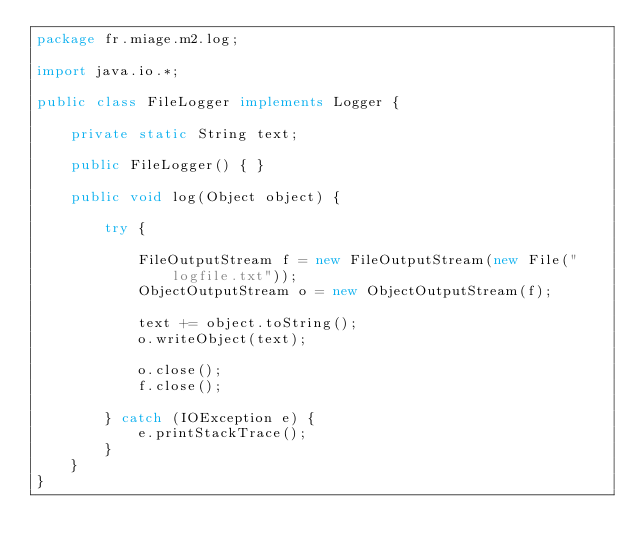Convert code to text. <code><loc_0><loc_0><loc_500><loc_500><_Java_>package fr.miage.m2.log;

import java.io.*;

public class FileLogger implements Logger {

    private static String text;

    public FileLogger() { }

    public void log(Object object) {

        try {

            FileOutputStream f = new FileOutputStream(new File("logfile.txt"));
            ObjectOutputStream o = new ObjectOutputStream(f);

            text += object.toString();
            o.writeObject(text);

            o.close();
            f.close();

        } catch (IOException e) {
            e.printStackTrace();
        }
    }
}
</code> 